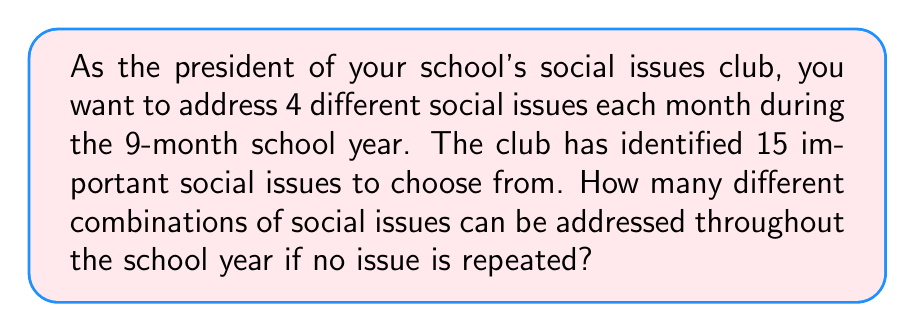Teach me how to tackle this problem. Let's approach this step-by-step:

1) We need to choose 4 issues each month for 9 months, without repetition.

2) This is a combination problem, as the order of selection doesn't matter within each month.

3) We can use the combination formula: $C(n,r) = \frac{n!}{r!(n-r)!}$

4) For the first month, we have:
   $C(15,4) = \frac{15!}{4!(15-4)!} = \frac{15!}{4!11!} = 1365$

5) For the second month, we have 11 issues left:
   $C(11,4) = \frac{11!}{4!(11-4)!} = \frac{11!}{4!7!} = 330$

6) Continuing this pattern:
   3rd month: $C(7,4) = 35$
   4th month: $C(3,3) = 1$

7) After the 4th month, we've used all 15 issues. For the remaining 5 months, there's only one way to choose (all issues must be reused).

8) Using the multiplication principle, the total number of combinations is:
   $1365 \times 330 \times 35 \times 1 \times 1 \times 1 \times 1 \times 1 \times 1$

9) Calculating this:
   $1365 \times 330 \times 35 = 15,783,750$

Therefore, there are 15,783,750 different combinations of social issues that can be addressed throughout the school year.
Answer: 15,783,750 